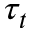<formula> <loc_0><loc_0><loc_500><loc_500>\tau _ { t }</formula> 